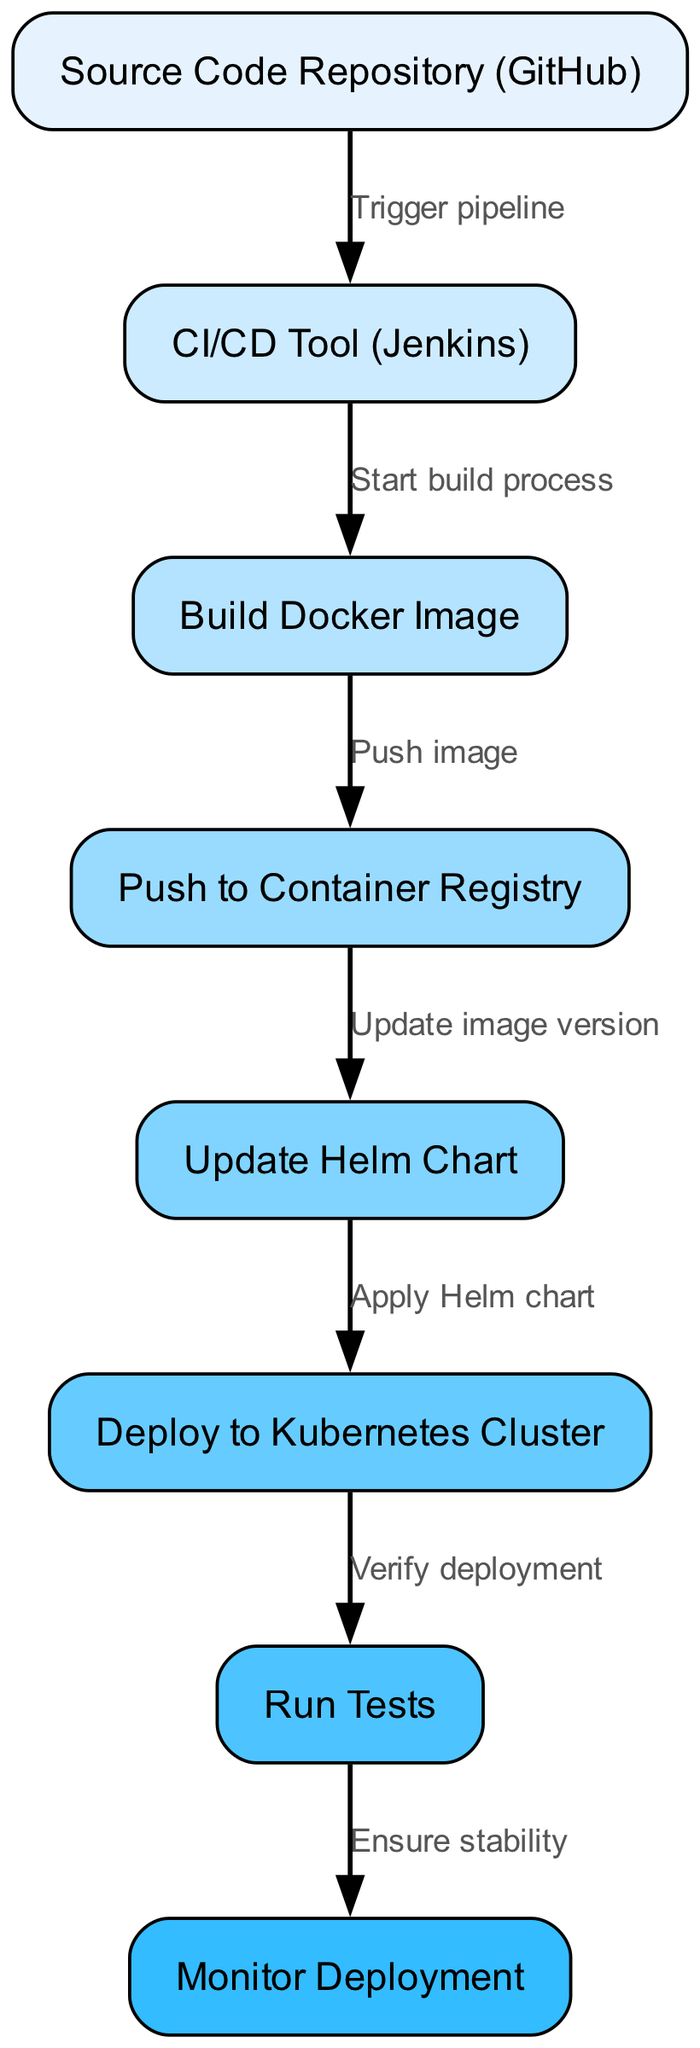What is the first node in the pipeline? The first node in the pipeline is identified as the source of the process, which is the Source Code Repository (GitHub). This node is labeled as the starting point in the diagram.
Answer: Source Code Repository (GitHub) How many nodes are present in the diagram? To determine the number of nodes, we count each node listed in the diagram. There are eight distinct nodes from the source code repository to the monitor deployment step.
Answer: 8 What is the last action taken in the pipeline? The last action taken in the pipeline is to ensure the stability of the deployment, which is represented by the node labeled Monitor Deployment. This is the final step in the flow.
Answer: Monitor Deployment What is the relationship between the Build Docker Image and Push to Container Registry nodes? The relationship is that the Build Docker Image node leads directly to the Push to Container Registry node, indicating that once the Docker image is built, it is then pushed to a container registry. This is a direct flow between the two actions.
Answer: Push image Which node is connected to both Deploy to Kubernetes Cluster and Run Tests? The node that connects to both Deploy to Kubernetes Cluster and Run Tests is the Update Helm Chart. After the Helm chart is updated, the pipeline proceeds to deploy and then verify the deployment through testing.
Answer: Update Helm Chart What process is initiated after the CI/CD Tool? The next process initiated after the CI/CD Tool is the Build Docker Image step, indicating that once the CI/CD tool triggers the pipeline, the build process begins with creating a Docker image.
Answer: Start build process What is the function of the edge between Push to Container Registry and Update Helm Chart? The edge represents the step of updating the image version after pushing the Docker image to the container registry, indicating that the deployment needs to reference the new version of the image.
Answer: Update image version Which node comes immediately before the Verify deployment step? The node that comes immediately before the Verify deployment step is Deploy to Kubernetes Cluster, showing the sequence that deployment occurs prior to testing and verification.
Answer: Deploy to Kubernetes Cluster What is the purpose of the Monitor Deployment node in the pipeline? The Monitor Deployment node serves the purpose of ensuring stability after deployment. It is the final verification step to confirm that the deployment is functioning as expected.
Answer: Ensure stability 